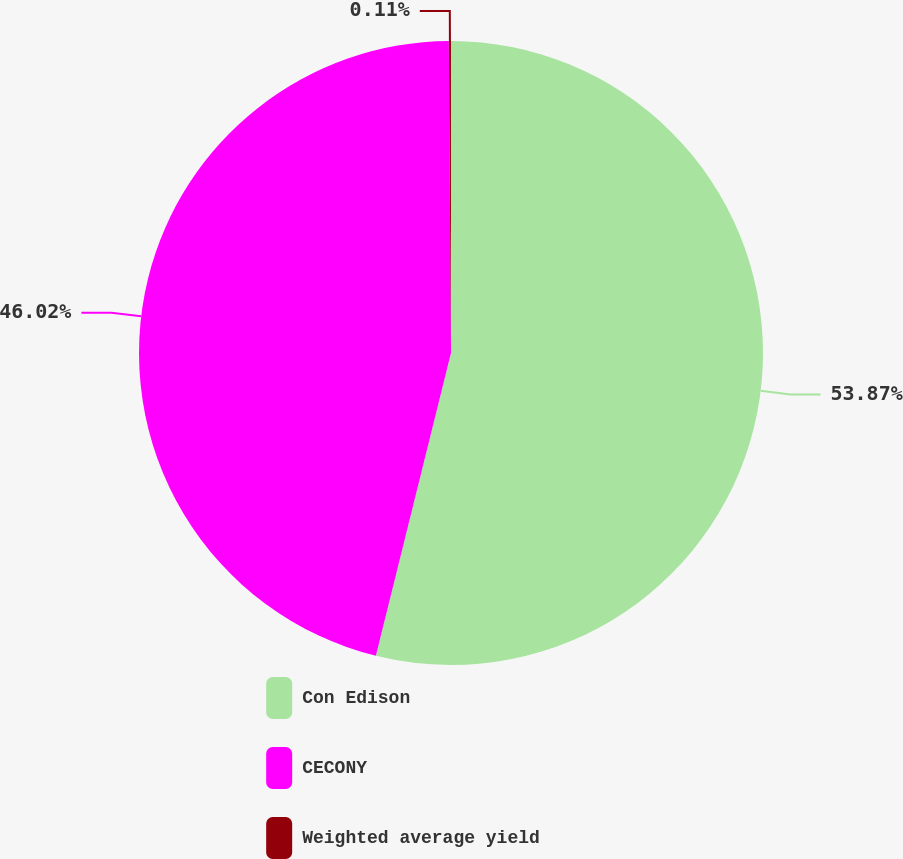Convert chart to OTSL. <chart><loc_0><loc_0><loc_500><loc_500><pie_chart><fcel>Con Edison<fcel>CECONY<fcel>Weighted average yield<nl><fcel>53.87%<fcel>46.02%<fcel>0.11%<nl></chart> 